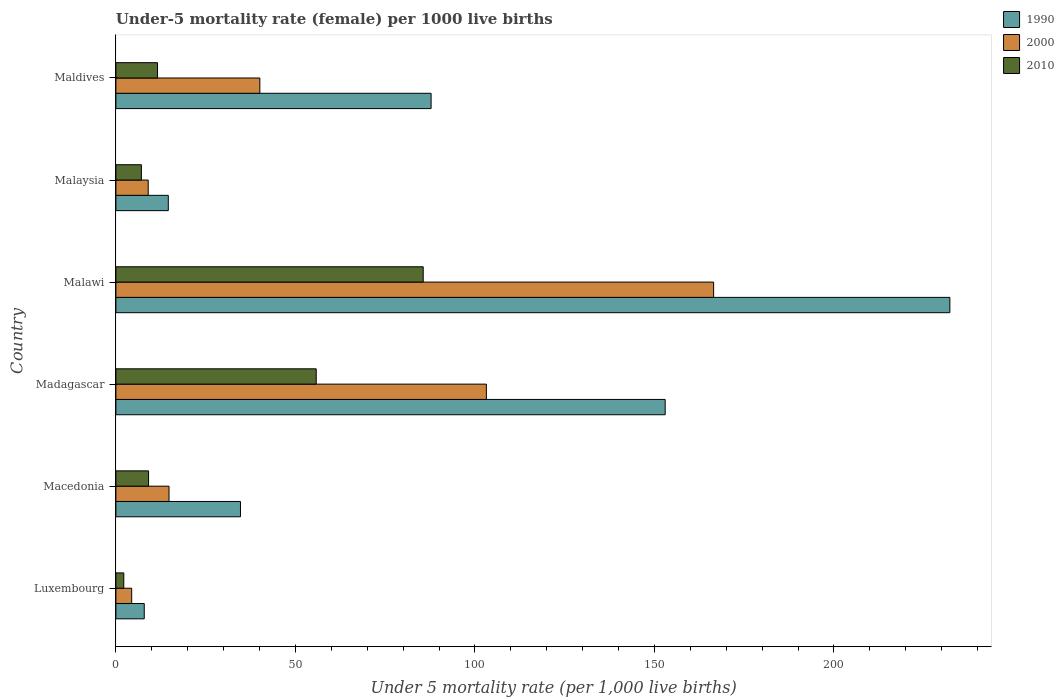How many different coloured bars are there?
Give a very brief answer. 3. Are the number of bars on each tick of the Y-axis equal?
Provide a short and direct response. Yes. How many bars are there on the 1st tick from the top?
Offer a very short reply. 3. How many bars are there on the 2nd tick from the bottom?
Your answer should be very brief. 3. What is the label of the 3rd group of bars from the top?
Offer a very short reply. Malawi. Across all countries, what is the maximum under-five mortality rate in 1990?
Make the answer very short. 232.3. Across all countries, what is the minimum under-five mortality rate in 1990?
Offer a terse response. 7.9. In which country was the under-five mortality rate in 2010 maximum?
Your answer should be very brief. Malawi. In which country was the under-five mortality rate in 2010 minimum?
Offer a terse response. Luxembourg. What is the total under-five mortality rate in 1990 in the graph?
Offer a very short reply. 530.3. What is the difference between the under-five mortality rate in 1990 in Malawi and that in Maldives?
Ensure brevity in your answer.  144.5. What is the difference between the under-five mortality rate in 2000 in Malaysia and the under-five mortality rate in 1990 in Macedonia?
Your answer should be very brief. -25.7. What is the average under-five mortality rate in 1990 per country?
Your answer should be very brief. 88.38. What is the ratio of the under-five mortality rate in 2010 in Malawi to that in Malaysia?
Give a very brief answer. 12.06. Is the under-five mortality rate in 2010 in Luxembourg less than that in Madagascar?
Give a very brief answer. Yes. What is the difference between the highest and the second highest under-five mortality rate in 2000?
Give a very brief answer. 63.3. What is the difference between the highest and the lowest under-five mortality rate in 1990?
Offer a terse response. 224.4. In how many countries, is the under-five mortality rate in 2010 greater than the average under-five mortality rate in 2010 taken over all countries?
Your response must be concise. 2. What does the 2nd bar from the top in Malawi represents?
Your answer should be very brief. 2000. Is it the case that in every country, the sum of the under-five mortality rate in 2000 and under-five mortality rate in 2010 is greater than the under-five mortality rate in 1990?
Provide a succinct answer. No. What is the difference between two consecutive major ticks on the X-axis?
Offer a terse response. 50. Does the graph contain any zero values?
Provide a succinct answer. No. Does the graph contain grids?
Keep it short and to the point. No. How many legend labels are there?
Your answer should be very brief. 3. How are the legend labels stacked?
Your answer should be compact. Vertical. What is the title of the graph?
Give a very brief answer. Under-5 mortality rate (female) per 1000 live births. What is the label or title of the X-axis?
Keep it short and to the point. Under 5 mortality rate (per 1,0 live births). What is the label or title of the Y-axis?
Offer a terse response. Country. What is the Under 5 mortality rate (per 1,000 live births) of 1990 in Luxembourg?
Your answer should be very brief. 7.9. What is the Under 5 mortality rate (per 1,000 live births) in 2000 in Luxembourg?
Ensure brevity in your answer.  4.4. What is the Under 5 mortality rate (per 1,000 live births) of 2010 in Luxembourg?
Your answer should be very brief. 2.2. What is the Under 5 mortality rate (per 1,000 live births) of 1990 in Macedonia?
Your response must be concise. 34.7. What is the Under 5 mortality rate (per 1,000 live births) in 1990 in Madagascar?
Ensure brevity in your answer.  153. What is the Under 5 mortality rate (per 1,000 live births) of 2000 in Madagascar?
Provide a succinct answer. 103.2. What is the Under 5 mortality rate (per 1,000 live births) in 2010 in Madagascar?
Your response must be concise. 55.8. What is the Under 5 mortality rate (per 1,000 live births) of 1990 in Malawi?
Give a very brief answer. 232.3. What is the Under 5 mortality rate (per 1,000 live births) of 2000 in Malawi?
Offer a very short reply. 166.5. What is the Under 5 mortality rate (per 1,000 live births) in 2010 in Malawi?
Provide a short and direct response. 85.6. What is the Under 5 mortality rate (per 1,000 live births) of 1990 in Malaysia?
Your answer should be very brief. 14.6. What is the Under 5 mortality rate (per 1,000 live births) of 2000 in Malaysia?
Ensure brevity in your answer.  9. What is the Under 5 mortality rate (per 1,000 live births) in 1990 in Maldives?
Offer a very short reply. 87.8. What is the Under 5 mortality rate (per 1,000 live births) of 2000 in Maldives?
Ensure brevity in your answer.  40.1. What is the Under 5 mortality rate (per 1,000 live births) in 2010 in Maldives?
Your response must be concise. 11.6. Across all countries, what is the maximum Under 5 mortality rate (per 1,000 live births) of 1990?
Offer a terse response. 232.3. Across all countries, what is the maximum Under 5 mortality rate (per 1,000 live births) of 2000?
Ensure brevity in your answer.  166.5. Across all countries, what is the maximum Under 5 mortality rate (per 1,000 live births) in 2010?
Offer a very short reply. 85.6. Across all countries, what is the minimum Under 5 mortality rate (per 1,000 live births) of 1990?
Your answer should be very brief. 7.9. Across all countries, what is the minimum Under 5 mortality rate (per 1,000 live births) of 2010?
Offer a very short reply. 2.2. What is the total Under 5 mortality rate (per 1,000 live births) of 1990 in the graph?
Your answer should be compact. 530.3. What is the total Under 5 mortality rate (per 1,000 live births) in 2000 in the graph?
Your answer should be compact. 338. What is the total Under 5 mortality rate (per 1,000 live births) of 2010 in the graph?
Give a very brief answer. 171.4. What is the difference between the Under 5 mortality rate (per 1,000 live births) in 1990 in Luxembourg and that in Macedonia?
Offer a terse response. -26.8. What is the difference between the Under 5 mortality rate (per 1,000 live births) of 2000 in Luxembourg and that in Macedonia?
Ensure brevity in your answer.  -10.4. What is the difference between the Under 5 mortality rate (per 1,000 live births) in 2010 in Luxembourg and that in Macedonia?
Offer a very short reply. -6.9. What is the difference between the Under 5 mortality rate (per 1,000 live births) of 1990 in Luxembourg and that in Madagascar?
Ensure brevity in your answer.  -145.1. What is the difference between the Under 5 mortality rate (per 1,000 live births) of 2000 in Luxembourg and that in Madagascar?
Your answer should be very brief. -98.8. What is the difference between the Under 5 mortality rate (per 1,000 live births) in 2010 in Luxembourg and that in Madagascar?
Your answer should be compact. -53.6. What is the difference between the Under 5 mortality rate (per 1,000 live births) of 1990 in Luxembourg and that in Malawi?
Your answer should be very brief. -224.4. What is the difference between the Under 5 mortality rate (per 1,000 live births) of 2000 in Luxembourg and that in Malawi?
Make the answer very short. -162.1. What is the difference between the Under 5 mortality rate (per 1,000 live births) in 2010 in Luxembourg and that in Malawi?
Provide a succinct answer. -83.4. What is the difference between the Under 5 mortality rate (per 1,000 live births) of 1990 in Luxembourg and that in Malaysia?
Your answer should be compact. -6.7. What is the difference between the Under 5 mortality rate (per 1,000 live births) in 2010 in Luxembourg and that in Malaysia?
Ensure brevity in your answer.  -4.9. What is the difference between the Under 5 mortality rate (per 1,000 live births) of 1990 in Luxembourg and that in Maldives?
Make the answer very short. -79.9. What is the difference between the Under 5 mortality rate (per 1,000 live births) of 2000 in Luxembourg and that in Maldives?
Your answer should be very brief. -35.7. What is the difference between the Under 5 mortality rate (per 1,000 live births) of 1990 in Macedonia and that in Madagascar?
Ensure brevity in your answer.  -118.3. What is the difference between the Under 5 mortality rate (per 1,000 live births) in 2000 in Macedonia and that in Madagascar?
Give a very brief answer. -88.4. What is the difference between the Under 5 mortality rate (per 1,000 live births) of 2010 in Macedonia and that in Madagascar?
Offer a terse response. -46.7. What is the difference between the Under 5 mortality rate (per 1,000 live births) in 1990 in Macedonia and that in Malawi?
Your response must be concise. -197.6. What is the difference between the Under 5 mortality rate (per 1,000 live births) in 2000 in Macedonia and that in Malawi?
Make the answer very short. -151.7. What is the difference between the Under 5 mortality rate (per 1,000 live births) of 2010 in Macedonia and that in Malawi?
Your answer should be very brief. -76.5. What is the difference between the Under 5 mortality rate (per 1,000 live births) of 1990 in Macedonia and that in Malaysia?
Offer a very short reply. 20.1. What is the difference between the Under 5 mortality rate (per 1,000 live births) of 2010 in Macedonia and that in Malaysia?
Make the answer very short. 2. What is the difference between the Under 5 mortality rate (per 1,000 live births) in 1990 in Macedonia and that in Maldives?
Offer a very short reply. -53.1. What is the difference between the Under 5 mortality rate (per 1,000 live births) in 2000 in Macedonia and that in Maldives?
Give a very brief answer. -25.3. What is the difference between the Under 5 mortality rate (per 1,000 live births) in 1990 in Madagascar and that in Malawi?
Offer a terse response. -79.3. What is the difference between the Under 5 mortality rate (per 1,000 live births) in 2000 in Madagascar and that in Malawi?
Your answer should be very brief. -63.3. What is the difference between the Under 5 mortality rate (per 1,000 live births) of 2010 in Madagascar and that in Malawi?
Your answer should be compact. -29.8. What is the difference between the Under 5 mortality rate (per 1,000 live births) of 1990 in Madagascar and that in Malaysia?
Make the answer very short. 138.4. What is the difference between the Under 5 mortality rate (per 1,000 live births) in 2000 in Madagascar and that in Malaysia?
Keep it short and to the point. 94.2. What is the difference between the Under 5 mortality rate (per 1,000 live births) in 2010 in Madagascar and that in Malaysia?
Offer a very short reply. 48.7. What is the difference between the Under 5 mortality rate (per 1,000 live births) of 1990 in Madagascar and that in Maldives?
Offer a terse response. 65.2. What is the difference between the Under 5 mortality rate (per 1,000 live births) in 2000 in Madagascar and that in Maldives?
Give a very brief answer. 63.1. What is the difference between the Under 5 mortality rate (per 1,000 live births) in 2010 in Madagascar and that in Maldives?
Keep it short and to the point. 44.2. What is the difference between the Under 5 mortality rate (per 1,000 live births) of 1990 in Malawi and that in Malaysia?
Give a very brief answer. 217.7. What is the difference between the Under 5 mortality rate (per 1,000 live births) of 2000 in Malawi and that in Malaysia?
Provide a short and direct response. 157.5. What is the difference between the Under 5 mortality rate (per 1,000 live births) in 2010 in Malawi and that in Malaysia?
Provide a succinct answer. 78.5. What is the difference between the Under 5 mortality rate (per 1,000 live births) in 1990 in Malawi and that in Maldives?
Give a very brief answer. 144.5. What is the difference between the Under 5 mortality rate (per 1,000 live births) of 2000 in Malawi and that in Maldives?
Your response must be concise. 126.4. What is the difference between the Under 5 mortality rate (per 1,000 live births) in 2010 in Malawi and that in Maldives?
Provide a short and direct response. 74. What is the difference between the Under 5 mortality rate (per 1,000 live births) in 1990 in Malaysia and that in Maldives?
Your answer should be compact. -73.2. What is the difference between the Under 5 mortality rate (per 1,000 live births) in 2000 in Malaysia and that in Maldives?
Provide a succinct answer. -31.1. What is the difference between the Under 5 mortality rate (per 1,000 live births) of 1990 in Luxembourg and the Under 5 mortality rate (per 1,000 live births) of 2000 in Macedonia?
Make the answer very short. -6.9. What is the difference between the Under 5 mortality rate (per 1,000 live births) in 1990 in Luxembourg and the Under 5 mortality rate (per 1,000 live births) in 2010 in Macedonia?
Offer a terse response. -1.2. What is the difference between the Under 5 mortality rate (per 1,000 live births) of 2000 in Luxembourg and the Under 5 mortality rate (per 1,000 live births) of 2010 in Macedonia?
Your answer should be compact. -4.7. What is the difference between the Under 5 mortality rate (per 1,000 live births) in 1990 in Luxembourg and the Under 5 mortality rate (per 1,000 live births) in 2000 in Madagascar?
Ensure brevity in your answer.  -95.3. What is the difference between the Under 5 mortality rate (per 1,000 live births) in 1990 in Luxembourg and the Under 5 mortality rate (per 1,000 live births) in 2010 in Madagascar?
Make the answer very short. -47.9. What is the difference between the Under 5 mortality rate (per 1,000 live births) in 2000 in Luxembourg and the Under 5 mortality rate (per 1,000 live births) in 2010 in Madagascar?
Ensure brevity in your answer.  -51.4. What is the difference between the Under 5 mortality rate (per 1,000 live births) in 1990 in Luxembourg and the Under 5 mortality rate (per 1,000 live births) in 2000 in Malawi?
Your response must be concise. -158.6. What is the difference between the Under 5 mortality rate (per 1,000 live births) of 1990 in Luxembourg and the Under 5 mortality rate (per 1,000 live births) of 2010 in Malawi?
Your response must be concise. -77.7. What is the difference between the Under 5 mortality rate (per 1,000 live births) of 2000 in Luxembourg and the Under 5 mortality rate (per 1,000 live births) of 2010 in Malawi?
Give a very brief answer. -81.2. What is the difference between the Under 5 mortality rate (per 1,000 live births) in 1990 in Luxembourg and the Under 5 mortality rate (per 1,000 live births) in 2000 in Malaysia?
Offer a terse response. -1.1. What is the difference between the Under 5 mortality rate (per 1,000 live births) in 2000 in Luxembourg and the Under 5 mortality rate (per 1,000 live births) in 2010 in Malaysia?
Offer a terse response. -2.7. What is the difference between the Under 5 mortality rate (per 1,000 live births) of 1990 in Luxembourg and the Under 5 mortality rate (per 1,000 live births) of 2000 in Maldives?
Provide a succinct answer. -32.2. What is the difference between the Under 5 mortality rate (per 1,000 live births) in 2000 in Luxembourg and the Under 5 mortality rate (per 1,000 live births) in 2010 in Maldives?
Offer a terse response. -7.2. What is the difference between the Under 5 mortality rate (per 1,000 live births) in 1990 in Macedonia and the Under 5 mortality rate (per 1,000 live births) in 2000 in Madagascar?
Keep it short and to the point. -68.5. What is the difference between the Under 5 mortality rate (per 1,000 live births) in 1990 in Macedonia and the Under 5 mortality rate (per 1,000 live births) in 2010 in Madagascar?
Your response must be concise. -21.1. What is the difference between the Under 5 mortality rate (per 1,000 live births) of 2000 in Macedonia and the Under 5 mortality rate (per 1,000 live births) of 2010 in Madagascar?
Give a very brief answer. -41. What is the difference between the Under 5 mortality rate (per 1,000 live births) of 1990 in Macedonia and the Under 5 mortality rate (per 1,000 live births) of 2000 in Malawi?
Ensure brevity in your answer.  -131.8. What is the difference between the Under 5 mortality rate (per 1,000 live births) in 1990 in Macedonia and the Under 5 mortality rate (per 1,000 live births) in 2010 in Malawi?
Offer a terse response. -50.9. What is the difference between the Under 5 mortality rate (per 1,000 live births) in 2000 in Macedonia and the Under 5 mortality rate (per 1,000 live births) in 2010 in Malawi?
Your answer should be very brief. -70.8. What is the difference between the Under 5 mortality rate (per 1,000 live births) of 1990 in Macedonia and the Under 5 mortality rate (per 1,000 live births) of 2000 in Malaysia?
Ensure brevity in your answer.  25.7. What is the difference between the Under 5 mortality rate (per 1,000 live births) in 1990 in Macedonia and the Under 5 mortality rate (per 1,000 live births) in 2010 in Malaysia?
Your answer should be compact. 27.6. What is the difference between the Under 5 mortality rate (per 1,000 live births) in 1990 in Macedonia and the Under 5 mortality rate (per 1,000 live births) in 2000 in Maldives?
Provide a short and direct response. -5.4. What is the difference between the Under 5 mortality rate (per 1,000 live births) of 1990 in Macedonia and the Under 5 mortality rate (per 1,000 live births) of 2010 in Maldives?
Provide a succinct answer. 23.1. What is the difference between the Under 5 mortality rate (per 1,000 live births) of 2000 in Macedonia and the Under 5 mortality rate (per 1,000 live births) of 2010 in Maldives?
Keep it short and to the point. 3.2. What is the difference between the Under 5 mortality rate (per 1,000 live births) of 1990 in Madagascar and the Under 5 mortality rate (per 1,000 live births) of 2010 in Malawi?
Keep it short and to the point. 67.4. What is the difference between the Under 5 mortality rate (per 1,000 live births) in 2000 in Madagascar and the Under 5 mortality rate (per 1,000 live births) in 2010 in Malawi?
Your response must be concise. 17.6. What is the difference between the Under 5 mortality rate (per 1,000 live births) of 1990 in Madagascar and the Under 5 mortality rate (per 1,000 live births) of 2000 in Malaysia?
Your answer should be compact. 144. What is the difference between the Under 5 mortality rate (per 1,000 live births) of 1990 in Madagascar and the Under 5 mortality rate (per 1,000 live births) of 2010 in Malaysia?
Offer a terse response. 145.9. What is the difference between the Under 5 mortality rate (per 1,000 live births) of 2000 in Madagascar and the Under 5 mortality rate (per 1,000 live births) of 2010 in Malaysia?
Provide a short and direct response. 96.1. What is the difference between the Under 5 mortality rate (per 1,000 live births) of 1990 in Madagascar and the Under 5 mortality rate (per 1,000 live births) of 2000 in Maldives?
Ensure brevity in your answer.  112.9. What is the difference between the Under 5 mortality rate (per 1,000 live births) of 1990 in Madagascar and the Under 5 mortality rate (per 1,000 live births) of 2010 in Maldives?
Your response must be concise. 141.4. What is the difference between the Under 5 mortality rate (per 1,000 live births) in 2000 in Madagascar and the Under 5 mortality rate (per 1,000 live births) in 2010 in Maldives?
Keep it short and to the point. 91.6. What is the difference between the Under 5 mortality rate (per 1,000 live births) of 1990 in Malawi and the Under 5 mortality rate (per 1,000 live births) of 2000 in Malaysia?
Provide a short and direct response. 223.3. What is the difference between the Under 5 mortality rate (per 1,000 live births) of 1990 in Malawi and the Under 5 mortality rate (per 1,000 live births) of 2010 in Malaysia?
Your answer should be very brief. 225.2. What is the difference between the Under 5 mortality rate (per 1,000 live births) in 2000 in Malawi and the Under 5 mortality rate (per 1,000 live births) in 2010 in Malaysia?
Your answer should be very brief. 159.4. What is the difference between the Under 5 mortality rate (per 1,000 live births) of 1990 in Malawi and the Under 5 mortality rate (per 1,000 live births) of 2000 in Maldives?
Your answer should be compact. 192.2. What is the difference between the Under 5 mortality rate (per 1,000 live births) in 1990 in Malawi and the Under 5 mortality rate (per 1,000 live births) in 2010 in Maldives?
Ensure brevity in your answer.  220.7. What is the difference between the Under 5 mortality rate (per 1,000 live births) of 2000 in Malawi and the Under 5 mortality rate (per 1,000 live births) of 2010 in Maldives?
Offer a terse response. 154.9. What is the difference between the Under 5 mortality rate (per 1,000 live births) of 1990 in Malaysia and the Under 5 mortality rate (per 1,000 live births) of 2000 in Maldives?
Your answer should be very brief. -25.5. What is the difference between the Under 5 mortality rate (per 1,000 live births) in 2000 in Malaysia and the Under 5 mortality rate (per 1,000 live births) in 2010 in Maldives?
Give a very brief answer. -2.6. What is the average Under 5 mortality rate (per 1,000 live births) of 1990 per country?
Give a very brief answer. 88.38. What is the average Under 5 mortality rate (per 1,000 live births) in 2000 per country?
Give a very brief answer. 56.33. What is the average Under 5 mortality rate (per 1,000 live births) of 2010 per country?
Ensure brevity in your answer.  28.57. What is the difference between the Under 5 mortality rate (per 1,000 live births) in 1990 and Under 5 mortality rate (per 1,000 live births) in 2010 in Luxembourg?
Provide a succinct answer. 5.7. What is the difference between the Under 5 mortality rate (per 1,000 live births) in 2000 and Under 5 mortality rate (per 1,000 live births) in 2010 in Luxembourg?
Make the answer very short. 2.2. What is the difference between the Under 5 mortality rate (per 1,000 live births) in 1990 and Under 5 mortality rate (per 1,000 live births) in 2000 in Macedonia?
Your response must be concise. 19.9. What is the difference between the Under 5 mortality rate (per 1,000 live births) in 1990 and Under 5 mortality rate (per 1,000 live births) in 2010 in Macedonia?
Make the answer very short. 25.6. What is the difference between the Under 5 mortality rate (per 1,000 live births) in 2000 and Under 5 mortality rate (per 1,000 live births) in 2010 in Macedonia?
Your response must be concise. 5.7. What is the difference between the Under 5 mortality rate (per 1,000 live births) in 1990 and Under 5 mortality rate (per 1,000 live births) in 2000 in Madagascar?
Keep it short and to the point. 49.8. What is the difference between the Under 5 mortality rate (per 1,000 live births) in 1990 and Under 5 mortality rate (per 1,000 live births) in 2010 in Madagascar?
Offer a terse response. 97.2. What is the difference between the Under 5 mortality rate (per 1,000 live births) of 2000 and Under 5 mortality rate (per 1,000 live births) of 2010 in Madagascar?
Give a very brief answer. 47.4. What is the difference between the Under 5 mortality rate (per 1,000 live births) of 1990 and Under 5 mortality rate (per 1,000 live births) of 2000 in Malawi?
Provide a short and direct response. 65.8. What is the difference between the Under 5 mortality rate (per 1,000 live births) of 1990 and Under 5 mortality rate (per 1,000 live births) of 2010 in Malawi?
Your response must be concise. 146.7. What is the difference between the Under 5 mortality rate (per 1,000 live births) of 2000 and Under 5 mortality rate (per 1,000 live births) of 2010 in Malawi?
Give a very brief answer. 80.9. What is the difference between the Under 5 mortality rate (per 1,000 live births) of 1990 and Under 5 mortality rate (per 1,000 live births) of 2000 in Malaysia?
Offer a very short reply. 5.6. What is the difference between the Under 5 mortality rate (per 1,000 live births) of 1990 and Under 5 mortality rate (per 1,000 live births) of 2010 in Malaysia?
Ensure brevity in your answer.  7.5. What is the difference between the Under 5 mortality rate (per 1,000 live births) in 1990 and Under 5 mortality rate (per 1,000 live births) in 2000 in Maldives?
Your response must be concise. 47.7. What is the difference between the Under 5 mortality rate (per 1,000 live births) in 1990 and Under 5 mortality rate (per 1,000 live births) in 2010 in Maldives?
Keep it short and to the point. 76.2. What is the difference between the Under 5 mortality rate (per 1,000 live births) in 2000 and Under 5 mortality rate (per 1,000 live births) in 2010 in Maldives?
Provide a short and direct response. 28.5. What is the ratio of the Under 5 mortality rate (per 1,000 live births) of 1990 in Luxembourg to that in Macedonia?
Give a very brief answer. 0.23. What is the ratio of the Under 5 mortality rate (per 1,000 live births) in 2000 in Luxembourg to that in Macedonia?
Provide a succinct answer. 0.3. What is the ratio of the Under 5 mortality rate (per 1,000 live births) in 2010 in Luxembourg to that in Macedonia?
Offer a very short reply. 0.24. What is the ratio of the Under 5 mortality rate (per 1,000 live births) in 1990 in Luxembourg to that in Madagascar?
Keep it short and to the point. 0.05. What is the ratio of the Under 5 mortality rate (per 1,000 live births) of 2000 in Luxembourg to that in Madagascar?
Offer a terse response. 0.04. What is the ratio of the Under 5 mortality rate (per 1,000 live births) in 2010 in Luxembourg to that in Madagascar?
Keep it short and to the point. 0.04. What is the ratio of the Under 5 mortality rate (per 1,000 live births) in 1990 in Luxembourg to that in Malawi?
Make the answer very short. 0.03. What is the ratio of the Under 5 mortality rate (per 1,000 live births) of 2000 in Luxembourg to that in Malawi?
Keep it short and to the point. 0.03. What is the ratio of the Under 5 mortality rate (per 1,000 live births) of 2010 in Luxembourg to that in Malawi?
Your answer should be compact. 0.03. What is the ratio of the Under 5 mortality rate (per 1,000 live births) of 1990 in Luxembourg to that in Malaysia?
Ensure brevity in your answer.  0.54. What is the ratio of the Under 5 mortality rate (per 1,000 live births) of 2000 in Luxembourg to that in Malaysia?
Offer a terse response. 0.49. What is the ratio of the Under 5 mortality rate (per 1,000 live births) of 2010 in Luxembourg to that in Malaysia?
Your answer should be very brief. 0.31. What is the ratio of the Under 5 mortality rate (per 1,000 live births) of 1990 in Luxembourg to that in Maldives?
Give a very brief answer. 0.09. What is the ratio of the Under 5 mortality rate (per 1,000 live births) in 2000 in Luxembourg to that in Maldives?
Give a very brief answer. 0.11. What is the ratio of the Under 5 mortality rate (per 1,000 live births) in 2010 in Luxembourg to that in Maldives?
Offer a terse response. 0.19. What is the ratio of the Under 5 mortality rate (per 1,000 live births) of 1990 in Macedonia to that in Madagascar?
Your response must be concise. 0.23. What is the ratio of the Under 5 mortality rate (per 1,000 live births) in 2000 in Macedonia to that in Madagascar?
Keep it short and to the point. 0.14. What is the ratio of the Under 5 mortality rate (per 1,000 live births) in 2010 in Macedonia to that in Madagascar?
Provide a short and direct response. 0.16. What is the ratio of the Under 5 mortality rate (per 1,000 live births) of 1990 in Macedonia to that in Malawi?
Your response must be concise. 0.15. What is the ratio of the Under 5 mortality rate (per 1,000 live births) of 2000 in Macedonia to that in Malawi?
Offer a terse response. 0.09. What is the ratio of the Under 5 mortality rate (per 1,000 live births) in 2010 in Macedonia to that in Malawi?
Keep it short and to the point. 0.11. What is the ratio of the Under 5 mortality rate (per 1,000 live births) of 1990 in Macedonia to that in Malaysia?
Your answer should be very brief. 2.38. What is the ratio of the Under 5 mortality rate (per 1,000 live births) of 2000 in Macedonia to that in Malaysia?
Provide a succinct answer. 1.64. What is the ratio of the Under 5 mortality rate (per 1,000 live births) in 2010 in Macedonia to that in Malaysia?
Your answer should be very brief. 1.28. What is the ratio of the Under 5 mortality rate (per 1,000 live births) of 1990 in Macedonia to that in Maldives?
Provide a short and direct response. 0.4. What is the ratio of the Under 5 mortality rate (per 1,000 live births) of 2000 in Macedonia to that in Maldives?
Your response must be concise. 0.37. What is the ratio of the Under 5 mortality rate (per 1,000 live births) of 2010 in Macedonia to that in Maldives?
Ensure brevity in your answer.  0.78. What is the ratio of the Under 5 mortality rate (per 1,000 live births) of 1990 in Madagascar to that in Malawi?
Your response must be concise. 0.66. What is the ratio of the Under 5 mortality rate (per 1,000 live births) of 2000 in Madagascar to that in Malawi?
Ensure brevity in your answer.  0.62. What is the ratio of the Under 5 mortality rate (per 1,000 live births) in 2010 in Madagascar to that in Malawi?
Keep it short and to the point. 0.65. What is the ratio of the Under 5 mortality rate (per 1,000 live births) in 1990 in Madagascar to that in Malaysia?
Your response must be concise. 10.48. What is the ratio of the Under 5 mortality rate (per 1,000 live births) of 2000 in Madagascar to that in Malaysia?
Offer a very short reply. 11.47. What is the ratio of the Under 5 mortality rate (per 1,000 live births) of 2010 in Madagascar to that in Malaysia?
Offer a terse response. 7.86. What is the ratio of the Under 5 mortality rate (per 1,000 live births) of 1990 in Madagascar to that in Maldives?
Ensure brevity in your answer.  1.74. What is the ratio of the Under 5 mortality rate (per 1,000 live births) in 2000 in Madagascar to that in Maldives?
Give a very brief answer. 2.57. What is the ratio of the Under 5 mortality rate (per 1,000 live births) in 2010 in Madagascar to that in Maldives?
Give a very brief answer. 4.81. What is the ratio of the Under 5 mortality rate (per 1,000 live births) of 1990 in Malawi to that in Malaysia?
Give a very brief answer. 15.91. What is the ratio of the Under 5 mortality rate (per 1,000 live births) in 2010 in Malawi to that in Malaysia?
Your answer should be very brief. 12.06. What is the ratio of the Under 5 mortality rate (per 1,000 live births) in 1990 in Malawi to that in Maldives?
Your answer should be very brief. 2.65. What is the ratio of the Under 5 mortality rate (per 1,000 live births) in 2000 in Malawi to that in Maldives?
Offer a terse response. 4.15. What is the ratio of the Under 5 mortality rate (per 1,000 live births) in 2010 in Malawi to that in Maldives?
Give a very brief answer. 7.38. What is the ratio of the Under 5 mortality rate (per 1,000 live births) of 1990 in Malaysia to that in Maldives?
Ensure brevity in your answer.  0.17. What is the ratio of the Under 5 mortality rate (per 1,000 live births) in 2000 in Malaysia to that in Maldives?
Give a very brief answer. 0.22. What is the ratio of the Under 5 mortality rate (per 1,000 live births) of 2010 in Malaysia to that in Maldives?
Your answer should be very brief. 0.61. What is the difference between the highest and the second highest Under 5 mortality rate (per 1,000 live births) in 1990?
Give a very brief answer. 79.3. What is the difference between the highest and the second highest Under 5 mortality rate (per 1,000 live births) of 2000?
Offer a terse response. 63.3. What is the difference between the highest and the second highest Under 5 mortality rate (per 1,000 live births) in 2010?
Provide a succinct answer. 29.8. What is the difference between the highest and the lowest Under 5 mortality rate (per 1,000 live births) of 1990?
Your response must be concise. 224.4. What is the difference between the highest and the lowest Under 5 mortality rate (per 1,000 live births) in 2000?
Your response must be concise. 162.1. What is the difference between the highest and the lowest Under 5 mortality rate (per 1,000 live births) in 2010?
Ensure brevity in your answer.  83.4. 